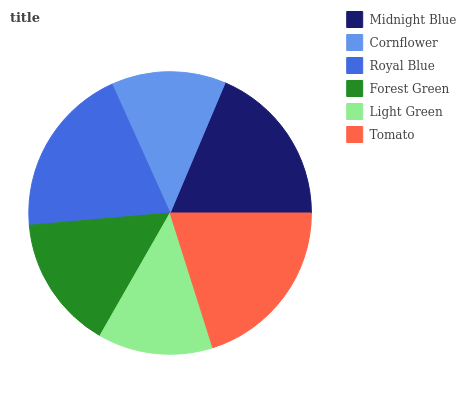Is Cornflower the minimum?
Answer yes or no. Yes. Is Tomato the maximum?
Answer yes or no. Yes. Is Royal Blue the minimum?
Answer yes or no. No. Is Royal Blue the maximum?
Answer yes or no. No. Is Royal Blue greater than Cornflower?
Answer yes or no. Yes. Is Cornflower less than Royal Blue?
Answer yes or no. Yes. Is Cornflower greater than Royal Blue?
Answer yes or no. No. Is Royal Blue less than Cornflower?
Answer yes or no. No. Is Midnight Blue the high median?
Answer yes or no. Yes. Is Forest Green the low median?
Answer yes or no. Yes. Is Light Green the high median?
Answer yes or no. No. Is Cornflower the low median?
Answer yes or no. No. 